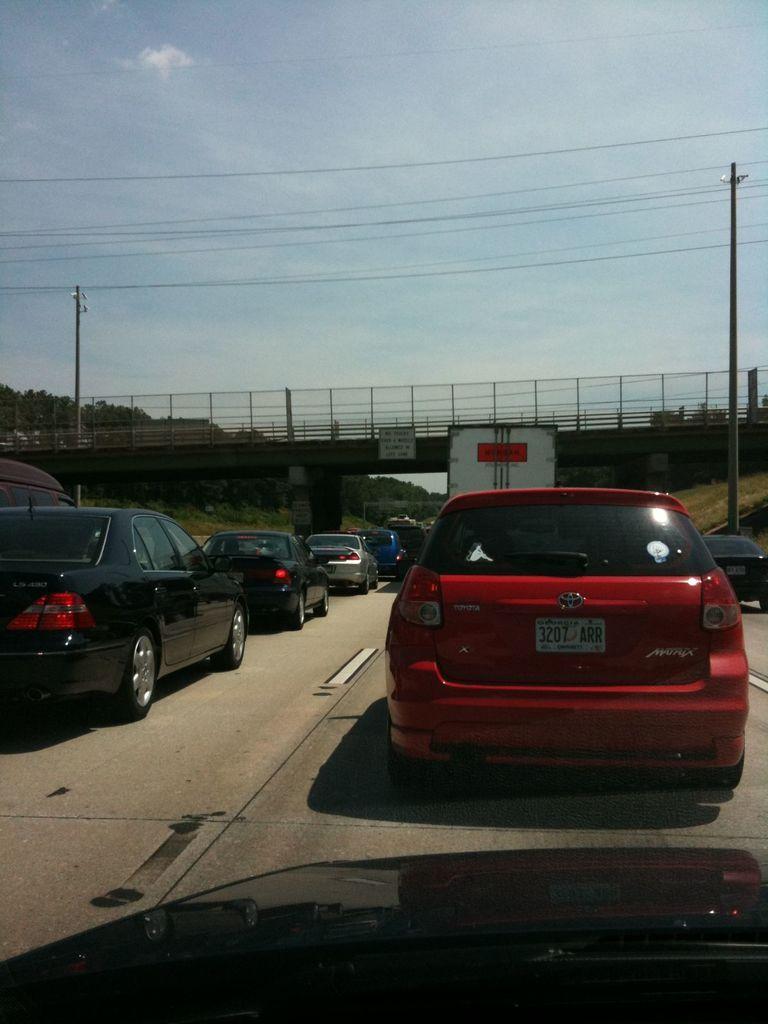How would you summarize this image in a sentence or two? In this image we can see cars on the road. In the background there is a bridge and we can see poles and trees. At the top there is sky and wires. 